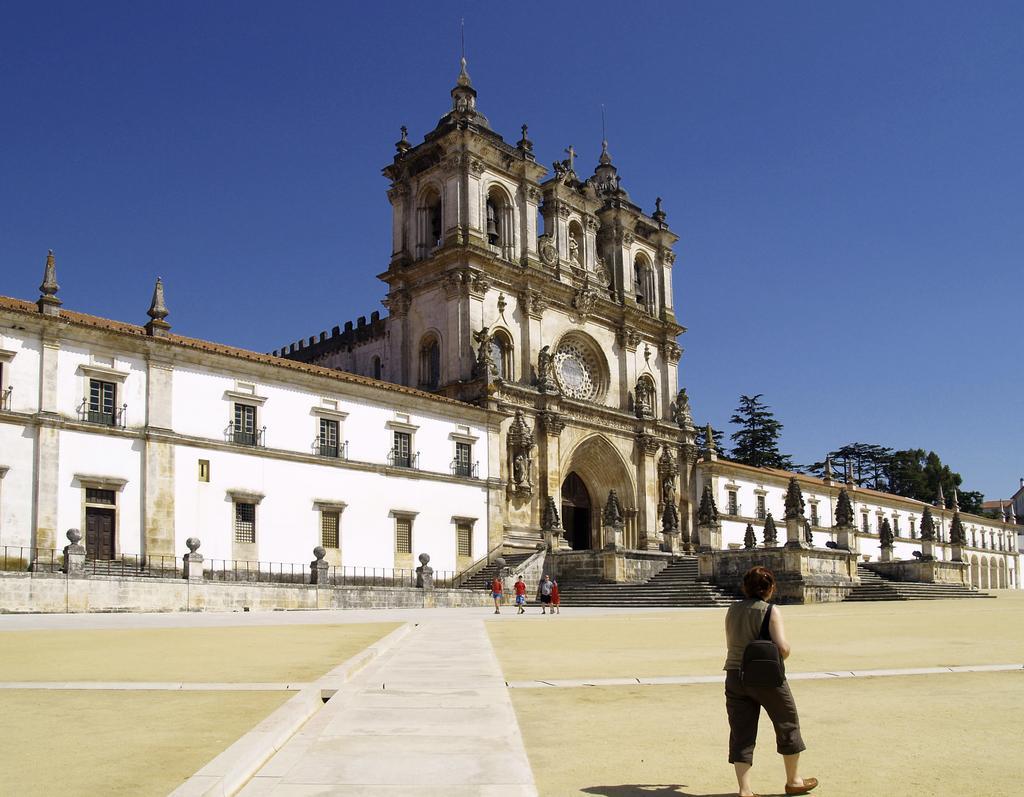Please provide a concise description of this image. This looks like a palace with windows. I can see an arch on the palace. These are the kind of pillars. I can see the stairs. There are few people walking. These are the trees. 